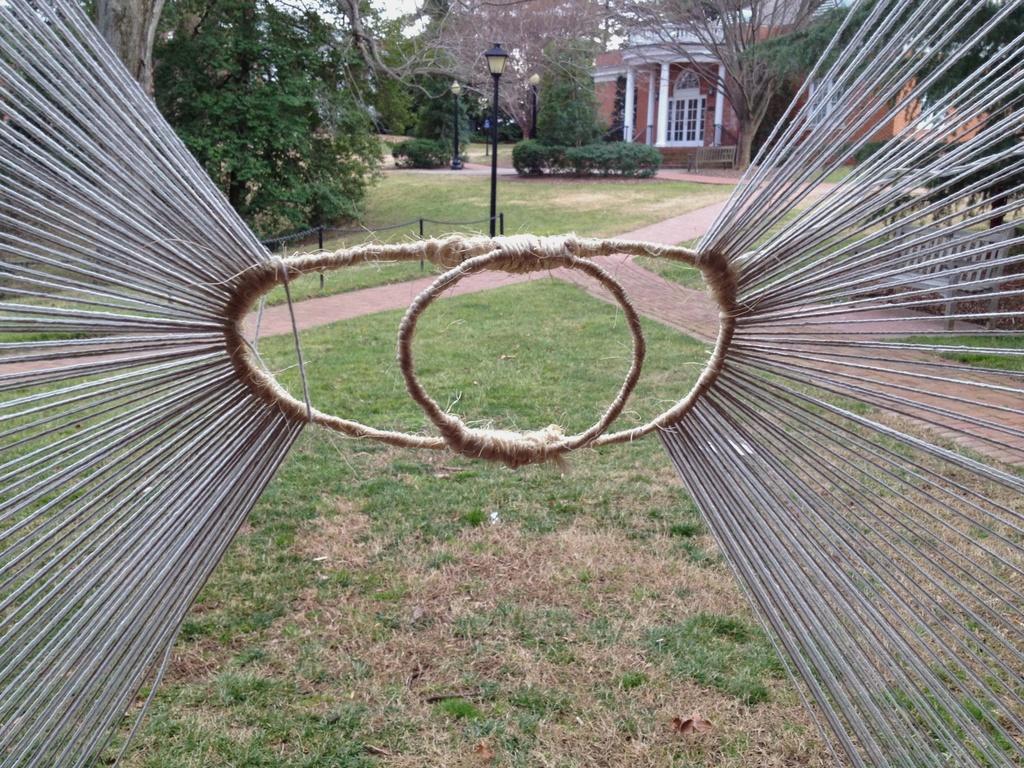Can you describe this image briefly? In this image in the front there is grass on the ground and there is a rope. In the background there are poles, trees and there is a house. 